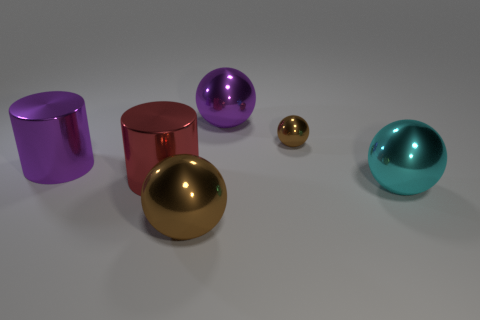Add 4 cylinders. How many objects exist? 10 Subtract all cylinders. How many objects are left? 4 Add 1 big cyan spheres. How many big cyan spheres are left? 2 Add 6 tiny gray metallic balls. How many tiny gray metallic balls exist? 6 Subtract 1 purple cylinders. How many objects are left? 5 Subtract all yellow metal objects. Subtract all small brown metal spheres. How many objects are left? 5 